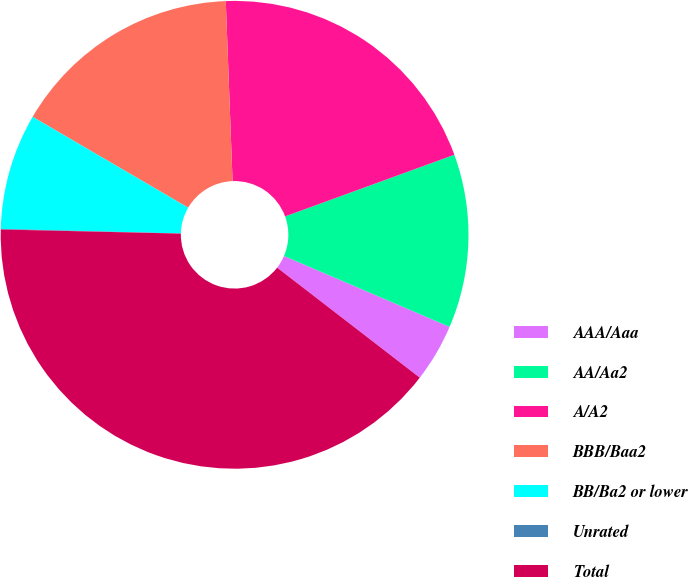<chart> <loc_0><loc_0><loc_500><loc_500><pie_chart><fcel>AAA/Aaa<fcel>AA/Aa2<fcel>A/A2<fcel>BBB/Baa2<fcel>BB/Ba2 or lower<fcel>Unrated<fcel>Total<nl><fcel>4.02%<fcel>12.0%<fcel>20.04%<fcel>15.99%<fcel>8.01%<fcel>0.04%<fcel>39.91%<nl></chart> 